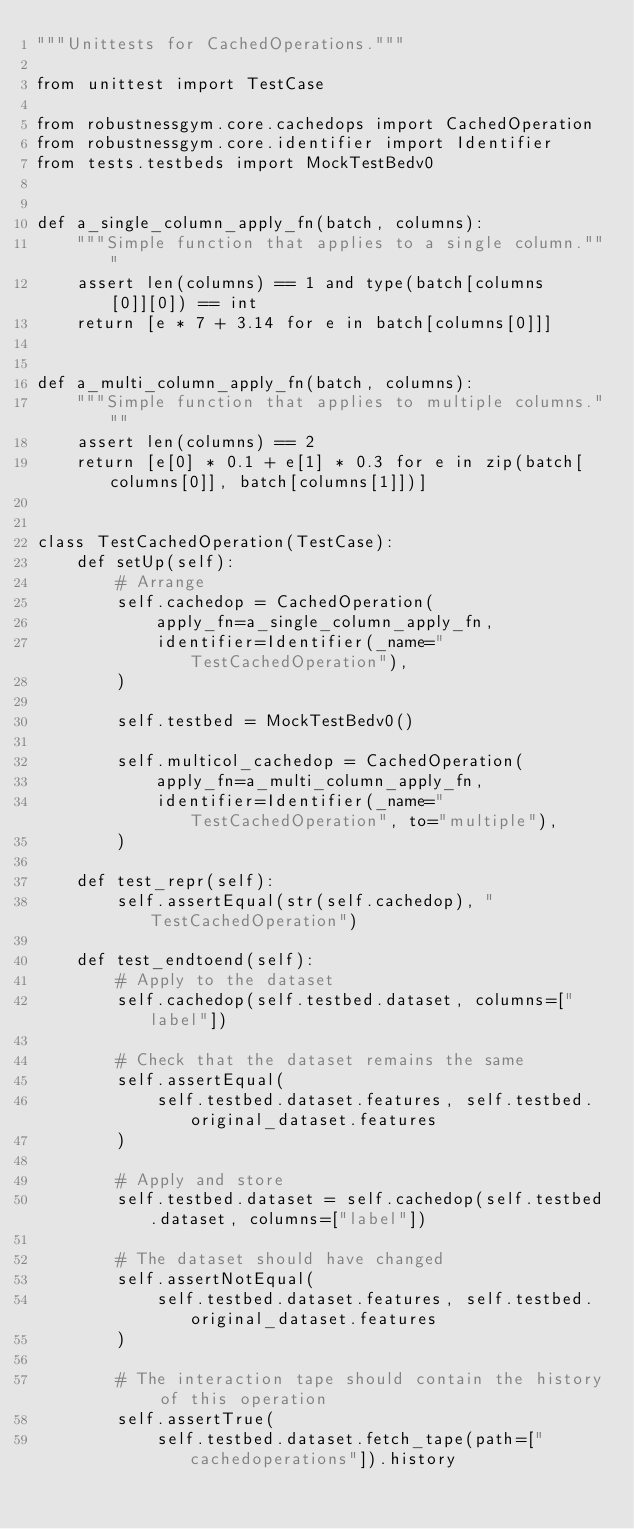Convert code to text. <code><loc_0><loc_0><loc_500><loc_500><_Python_>"""Unittests for CachedOperations."""

from unittest import TestCase

from robustnessgym.core.cachedops import CachedOperation
from robustnessgym.core.identifier import Identifier
from tests.testbeds import MockTestBedv0


def a_single_column_apply_fn(batch, columns):
    """Simple function that applies to a single column."""
    assert len(columns) == 1 and type(batch[columns[0]][0]) == int
    return [e * 7 + 3.14 for e in batch[columns[0]]]


def a_multi_column_apply_fn(batch, columns):
    """Simple function that applies to multiple columns."""
    assert len(columns) == 2
    return [e[0] * 0.1 + e[1] * 0.3 for e in zip(batch[columns[0]], batch[columns[1]])]


class TestCachedOperation(TestCase):
    def setUp(self):
        # Arrange
        self.cachedop = CachedOperation(
            apply_fn=a_single_column_apply_fn,
            identifier=Identifier(_name="TestCachedOperation"),
        )

        self.testbed = MockTestBedv0()

        self.multicol_cachedop = CachedOperation(
            apply_fn=a_multi_column_apply_fn,
            identifier=Identifier(_name="TestCachedOperation", to="multiple"),
        )

    def test_repr(self):
        self.assertEqual(str(self.cachedop), "TestCachedOperation")

    def test_endtoend(self):
        # Apply to the dataset
        self.cachedop(self.testbed.dataset, columns=["label"])

        # Check that the dataset remains the same
        self.assertEqual(
            self.testbed.dataset.features, self.testbed.original_dataset.features
        )

        # Apply and store
        self.testbed.dataset = self.cachedop(self.testbed.dataset, columns=["label"])

        # The dataset should have changed
        self.assertNotEqual(
            self.testbed.dataset.features, self.testbed.original_dataset.features
        )

        # The interaction tape should contain the history of this operation
        self.assertTrue(
            self.testbed.dataset.fetch_tape(path=["cachedoperations"]).history</code> 